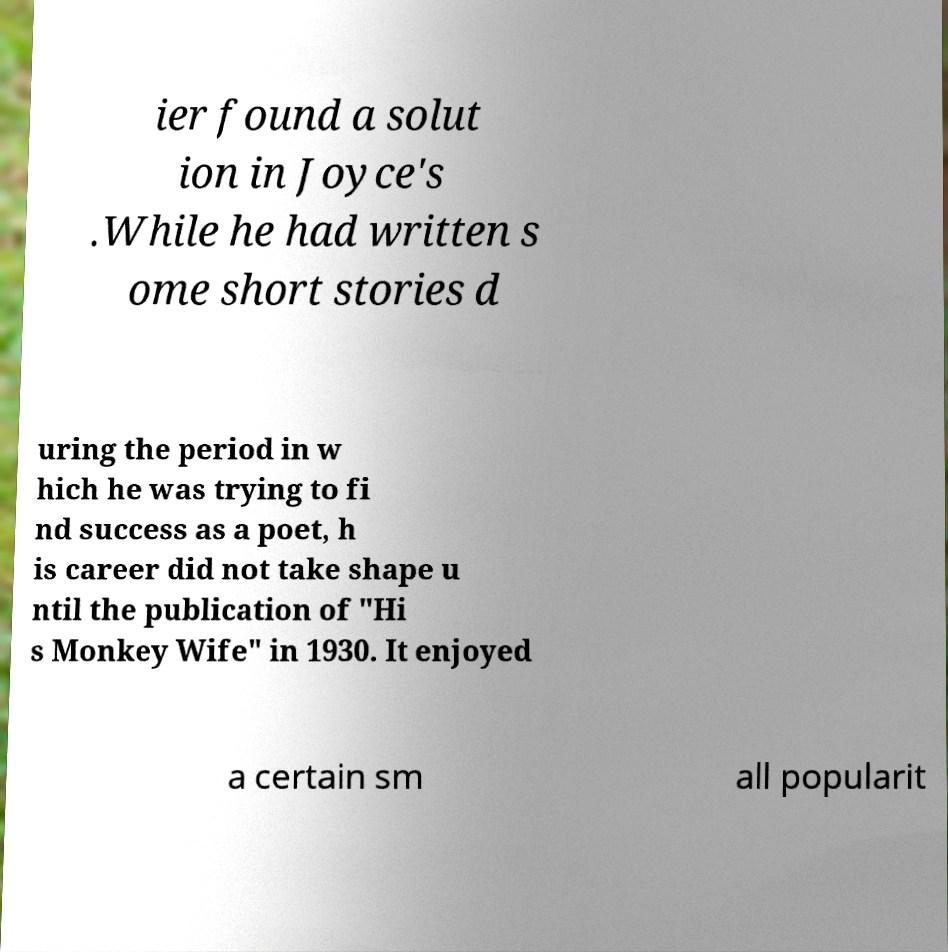What messages or text are displayed in this image? I need them in a readable, typed format. ier found a solut ion in Joyce's .While he had written s ome short stories d uring the period in w hich he was trying to fi nd success as a poet, h is career did not take shape u ntil the publication of "Hi s Monkey Wife" in 1930. It enjoyed a certain sm all popularit 